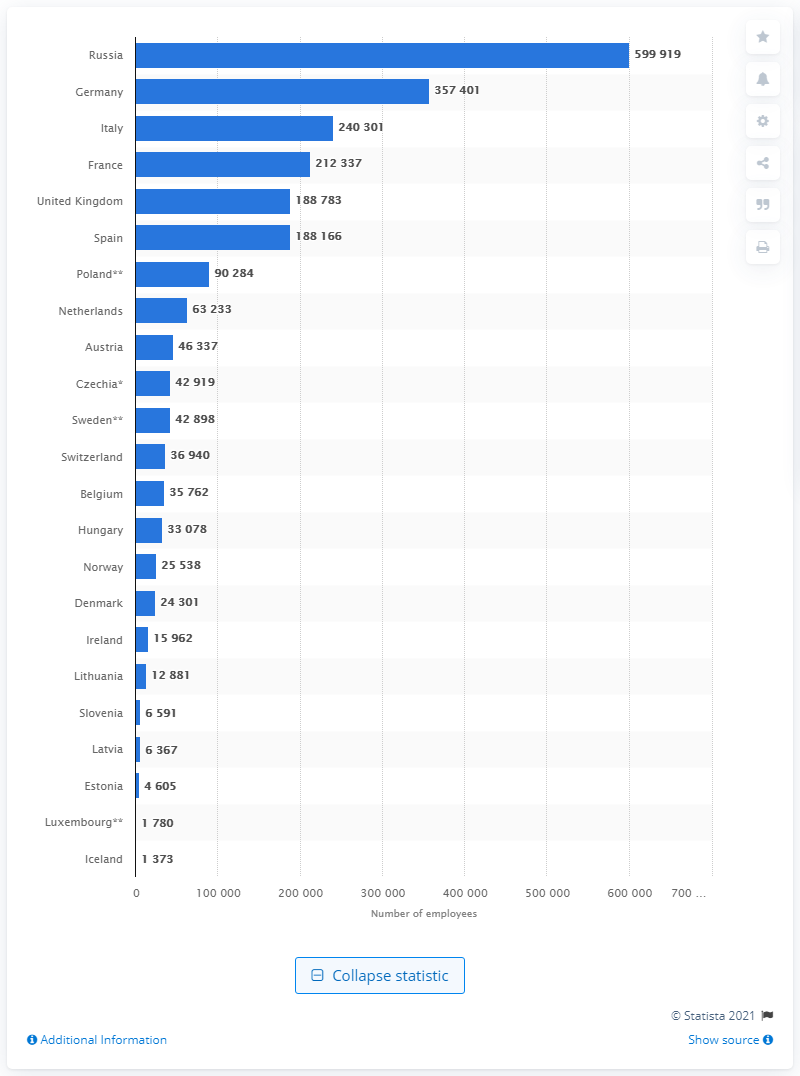List a handful of essential elements in this visual. In 2018, there were approximately 599,919 practicing physicians in Russia. In 2018, there were approximately 600 thousand practicing physicians in Russia, making it the country with the highest number of practicing physicians. 